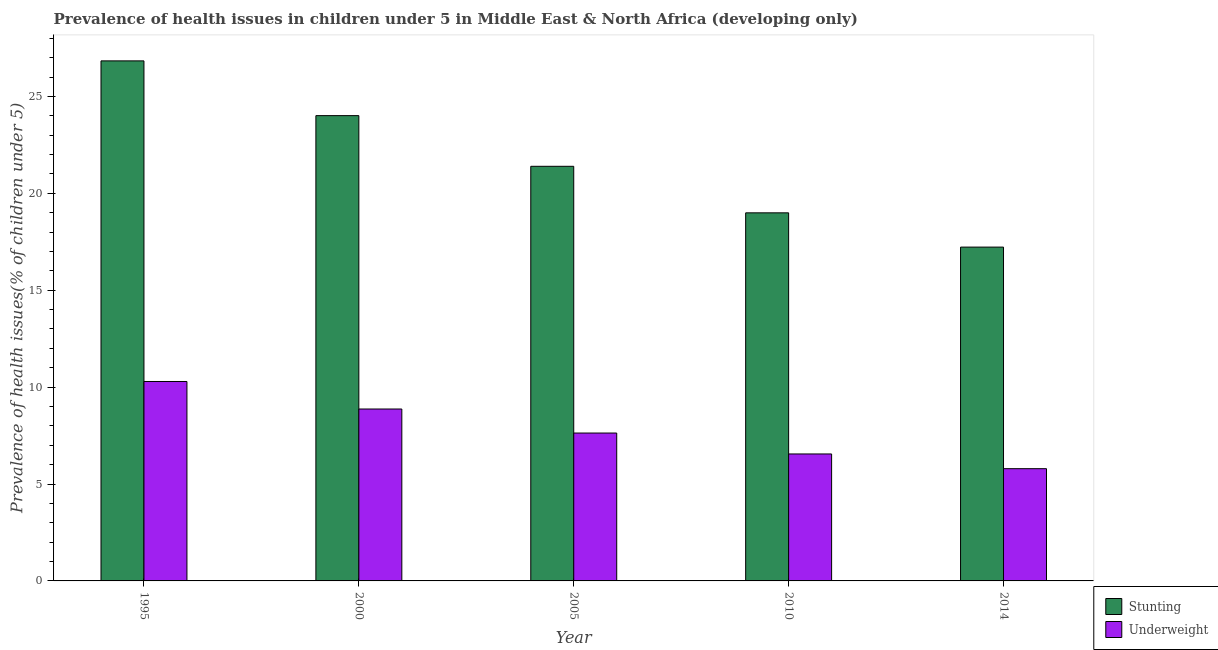How many bars are there on the 1st tick from the left?
Ensure brevity in your answer.  2. How many bars are there on the 5th tick from the right?
Your answer should be very brief. 2. What is the percentage of stunted children in 2010?
Keep it short and to the point. 18.99. Across all years, what is the maximum percentage of stunted children?
Offer a terse response. 26.83. Across all years, what is the minimum percentage of underweight children?
Offer a terse response. 5.79. In which year was the percentage of stunted children maximum?
Ensure brevity in your answer.  1995. In which year was the percentage of underweight children minimum?
Provide a succinct answer. 2014. What is the total percentage of stunted children in the graph?
Ensure brevity in your answer.  108.46. What is the difference between the percentage of stunted children in 2010 and that in 2014?
Provide a succinct answer. 1.77. What is the difference between the percentage of underweight children in 1995 and the percentage of stunted children in 2005?
Make the answer very short. 2.66. What is the average percentage of underweight children per year?
Ensure brevity in your answer.  7.83. In the year 2014, what is the difference between the percentage of underweight children and percentage of stunted children?
Your answer should be compact. 0. What is the ratio of the percentage of stunted children in 2005 to that in 2014?
Offer a terse response. 1.24. What is the difference between the highest and the second highest percentage of stunted children?
Your response must be concise. 2.83. What is the difference between the highest and the lowest percentage of underweight children?
Ensure brevity in your answer.  4.5. What does the 1st bar from the left in 1995 represents?
Offer a very short reply. Stunting. What does the 1st bar from the right in 1995 represents?
Offer a terse response. Underweight. Are all the bars in the graph horizontal?
Ensure brevity in your answer.  No. How many years are there in the graph?
Give a very brief answer. 5. Are the values on the major ticks of Y-axis written in scientific E-notation?
Your answer should be compact. No. How many legend labels are there?
Your response must be concise. 2. How are the legend labels stacked?
Provide a succinct answer. Vertical. What is the title of the graph?
Provide a succinct answer. Prevalence of health issues in children under 5 in Middle East & North Africa (developing only). Does "Secondary Education" appear as one of the legend labels in the graph?
Offer a very short reply. No. What is the label or title of the X-axis?
Provide a succinct answer. Year. What is the label or title of the Y-axis?
Your response must be concise. Prevalence of health issues(% of children under 5). What is the Prevalence of health issues(% of children under 5) in Stunting in 1995?
Provide a short and direct response. 26.83. What is the Prevalence of health issues(% of children under 5) in Underweight in 1995?
Your answer should be very brief. 10.29. What is the Prevalence of health issues(% of children under 5) in Stunting in 2000?
Your answer should be very brief. 24.01. What is the Prevalence of health issues(% of children under 5) of Underweight in 2000?
Ensure brevity in your answer.  8.87. What is the Prevalence of health issues(% of children under 5) of Stunting in 2005?
Offer a terse response. 21.39. What is the Prevalence of health issues(% of children under 5) in Underweight in 2005?
Ensure brevity in your answer.  7.63. What is the Prevalence of health issues(% of children under 5) in Stunting in 2010?
Offer a very short reply. 18.99. What is the Prevalence of health issues(% of children under 5) of Underweight in 2010?
Provide a succinct answer. 6.55. What is the Prevalence of health issues(% of children under 5) of Stunting in 2014?
Your answer should be compact. 17.23. What is the Prevalence of health issues(% of children under 5) of Underweight in 2014?
Provide a short and direct response. 5.79. Across all years, what is the maximum Prevalence of health issues(% of children under 5) in Stunting?
Keep it short and to the point. 26.83. Across all years, what is the maximum Prevalence of health issues(% of children under 5) of Underweight?
Provide a succinct answer. 10.29. Across all years, what is the minimum Prevalence of health issues(% of children under 5) in Stunting?
Offer a very short reply. 17.23. Across all years, what is the minimum Prevalence of health issues(% of children under 5) in Underweight?
Make the answer very short. 5.79. What is the total Prevalence of health issues(% of children under 5) in Stunting in the graph?
Your answer should be very brief. 108.46. What is the total Prevalence of health issues(% of children under 5) of Underweight in the graph?
Give a very brief answer. 39.14. What is the difference between the Prevalence of health issues(% of children under 5) of Stunting in 1995 and that in 2000?
Offer a terse response. 2.83. What is the difference between the Prevalence of health issues(% of children under 5) of Underweight in 1995 and that in 2000?
Provide a succinct answer. 1.42. What is the difference between the Prevalence of health issues(% of children under 5) in Stunting in 1995 and that in 2005?
Keep it short and to the point. 5.44. What is the difference between the Prevalence of health issues(% of children under 5) in Underweight in 1995 and that in 2005?
Make the answer very short. 2.66. What is the difference between the Prevalence of health issues(% of children under 5) of Stunting in 1995 and that in 2010?
Your answer should be compact. 7.84. What is the difference between the Prevalence of health issues(% of children under 5) in Underweight in 1995 and that in 2010?
Provide a succinct answer. 3.74. What is the difference between the Prevalence of health issues(% of children under 5) of Stunting in 1995 and that in 2014?
Provide a succinct answer. 9.61. What is the difference between the Prevalence of health issues(% of children under 5) of Underweight in 1995 and that in 2014?
Provide a succinct answer. 4.5. What is the difference between the Prevalence of health issues(% of children under 5) of Stunting in 2000 and that in 2005?
Offer a terse response. 2.61. What is the difference between the Prevalence of health issues(% of children under 5) in Underweight in 2000 and that in 2005?
Your answer should be compact. 1.24. What is the difference between the Prevalence of health issues(% of children under 5) in Stunting in 2000 and that in 2010?
Give a very brief answer. 5.02. What is the difference between the Prevalence of health issues(% of children under 5) of Underweight in 2000 and that in 2010?
Offer a very short reply. 2.32. What is the difference between the Prevalence of health issues(% of children under 5) of Stunting in 2000 and that in 2014?
Make the answer very short. 6.78. What is the difference between the Prevalence of health issues(% of children under 5) in Underweight in 2000 and that in 2014?
Provide a succinct answer. 3.08. What is the difference between the Prevalence of health issues(% of children under 5) in Stunting in 2005 and that in 2010?
Provide a short and direct response. 2.4. What is the difference between the Prevalence of health issues(% of children under 5) in Underweight in 2005 and that in 2010?
Give a very brief answer. 1.08. What is the difference between the Prevalence of health issues(% of children under 5) in Stunting in 2005 and that in 2014?
Make the answer very short. 4.17. What is the difference between the Prevalence of health issues(% of children under 5) in Underweight in 2005 and that in 2014?
Offer a terse response. 1.84. What is the difference between the Prevalence of health issues(% of children under 5) in Stunting in 2010 and that in 2014?
Keep it short and to the point. 1.77. What is the difference between the Prevalence of health issues(% of children under 5) of Underweight in 2010 and that in 2014?
Ensure brevity in your answer.  0.76. What is the difference between the Prevalence of health issues(% of children under 5) in Stunting in 1995 and the Prevalence of health issues(% of children under 5) in Underweight in 2000?
Give a very brief answer. 17.96. What is the difference between the Prevalence of health issues(% of children under 5) in Stunting in 1995 and the Prevalence of health issues(% of children under 5) in Underweight in 2005?
Offer a terse response. 19.2. What is the difference between the Prevalence of health issues(% of children under 5) of Stunting in 1995 and the Prevalence of health issues(% of children under 5) of Underweight in 2010?
Keep it short and to the point. 20.28. What is the difference between the Prevalence of health issues(% of children under 5) of Stunting in 1995 and the Prevalence of health issues(% of children under 5) of Underweight in 2014?
Your answer should be compact. 21.04. What is the difference between the Prevalence of health issues(% of children under 5) of Stunting in 2000 and the Prevalence of health issues(% of children under 5) of Underweight in 2005?
Offer a terse response. 16.38. What is the difference between the Prevalence of health issues(% of children under 5) of Stunting in 2000 and the Prevalence of health issues(% of children under 5) of Underweight in 2010?
Make the answer very short. 17.46. What is the difference between the Prevalence of health issues(% of children under 5) of Stunting in 2000 and the Prevalence of health issues(% of children under 5) of Underweight in 2014?
Your answer should be very brief. 18.22. What is the difference between the Prevalence of health issues(% of children under 5) of Stunting in 2005 and the Prevalence of health issues(% of children under 5) of Underweight in 2010?
Your answer should be compact. 14.84. What is the difference between the Prevalence of health issues(% of children under 5) of Stunting in 2005 and the Prevalence of health issues(% of children under 5) of Underweight in 2014?
Make the answer very short. 15.6. What is the difference between the Prevalence of health issues(% of children under 5) of Stunting in 2010 and the Prevalence of health issues(% of children under 5) of Underweight in 2014?
Provide a succinct answer. 13.2. What is the average Prevalence of health issues(% of children under 5) of Stunting per year?
Offer a terse response. 21.69. What is the average Prevalence of health issues(% of children under 5) in Underweight per year?
Ensure brevity in your answer.  7.83. In the year 1995, what is the difference between the Prevalence of health issues(% of children under 5) of Stunting and Prevalence of health issues(% of children under 5) of Underweight?
Ensure brevity in your answer.  16.54. In the year 2000, what is the difference between the Prevalence of health issues(% of children under 5) of Stunting and Prevalence of health issues(% of children under 5) of Underweight?
Your answer should be very brief. 15.14. In the year 2005, what is the difference between the Prevalence of health issues(% of children under 5) in Stunting and Prevalence of health issues(% of children under 5) in Underweight?
Make the answer very short. 13.76. In the year 2010, what is the difference between the Prevalence of health issues(% of children under 5) in Stunting and Prevalence of health issues(% of children under 5) in Underweight?
Provide a succinct answer. 12.44. In the year 2014, what is the difference between the Prevalence of health issues(% of children under 5) in Stunting and Prevalence of health issues(% of children under 5) in Underweight?
Your response must be concise. 11.43. What is the ratio of the Prevalence of health issues(% of children under 5) of Stunting in 1995 to that in 2000?
Your response must be concise. 1.12. What is the ratio of the Prevalence of health issues(% of children under 5) of Underweight in 1995 to that in 2000?
Your answer should be compact. 1.16. What is the ratio of the Prevalence of health issues(% of children under 5) of Stunting in 1995 to that in 2005?
Offer a terse response. 1.25. What is the ratio of the Prevalence of health issues(% of children under 5) of Underweight in 1995 to that in 2005?
Your answer should be very brief. 1.35. What is the ratio of the Prevalence of health issues(% of children under 5) of Stunting in 1995 to that in 2010?
Provide a short and direct response. 1.41. What is the ratio of the Prevalence of health issues(% of children under 5) of Underweight in 1995 to that in 2010?
Offer a very short reply. 1.57. What is the ratio of the Prevalence of health issues(% of children under 5) of Stunting in 1995 to that in 2014?
Ensure brevity in your answer.  1.56. What is the ratio of the Prevalence of health issues(% of children under 5) in Underweight in 1995 to that in 2014?
Keep it short and to the point. 1.78. What is the ratio of the Prevalence of health issues(% of children under 5) of Stunting in 2000 to that in 2005?
Your response must be concise. 1.12. What is the ratio of the Prevalence of health issues(% of children under 5) of Underweight in 2000 to that in 2005?
Provide a succinct answer. 1.16. What is the ratio of the Prevalence of health issues(% of children under 5) in Stunting in 2000 to that in 2010?
Ensure brevity in your answer.  1.26. What is the ratio of the Prevalence of health issues(% of children under 5) of Underweight in 2000 to that in 2010?
Provide a succinct answer. 1.35. What is the ratio of the Prevalence of health issues(% of children under 5) in Stunting in 2000 to that in 2014?
Your response must be concise. 1.39. What is the ratio of the Prevalence of health issues(% of children under 5) in Underweight in 2000 to that in 2014?
Give a very brief answer. 1.53. What is the ratio of the Prevalence of health issues(% of children under 5) in Stunting in 2005 to that in 2010?
Keep it short and to the point. 1.13. What is the ratio of the Prevalence of health issues(% of children under 5) in Underweight in 2005 to that in 2010?
Ensure brevity in your answer.  1.16. What is the ratio of the Prevalence of health issues(% of children under 5) of Stunting in 2005 to that in 2014?
Your answer should be compact. 1.24. What is the ratio of the Prevalence of health issues(% of children under 5) of Underweight in 2005 to that in 2014?
Your answer should be compact. 1.32. What is the ratio of the Prevalence of health issues(% of children under 5) of Stunting in 2010 to that in 2014?
Ensure brevity in your answer.  1.1. What is the ratio of the Prevalence of health issues(% of children under 5) in Underweight in 2010 to that in 2014?
Your response must be concise. 1.13. What is the difference between the highest and the second highest Prevalence of health issues(% of children under 5) in Stunting?
Ensure brevity in your answer.  2.83. What is the difference between the highest and the second highest Prevalence of health issues(% of children under 5) of Underweight?
Your response must be concise. 1.42. What is the difference between the highest and the lowest Prevalence of health issues(% of children under 5) in Stunting?
Provide a succinct answer. 9.61. What is the difference between the highest and the lowest Prevalence of health issues(% of children under 5) of Underweight?
Your answer should be very brief. 4.5. 